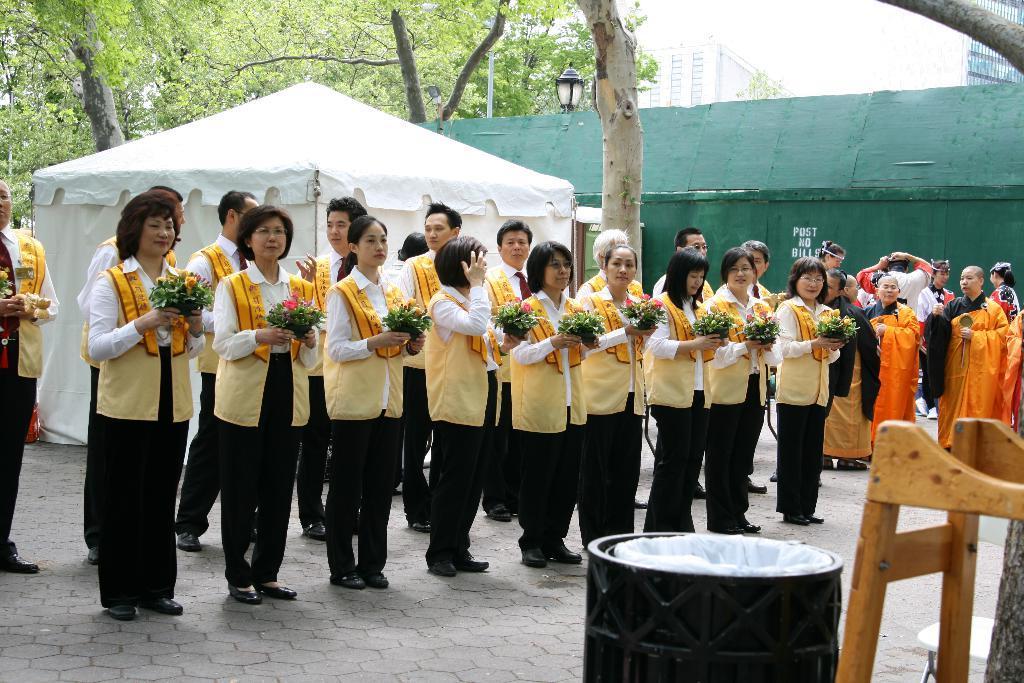In one or two sentences, can you explain what this image depicts? There are few women standing on the floor in the first row by holding a bouquet in their hands individually and behind there are few men standing on the floor. In the background there are tents,buildings,trees,light pole,on the right there are few people standing and sky. At the bottom there is a dustbin and a wooden object. 